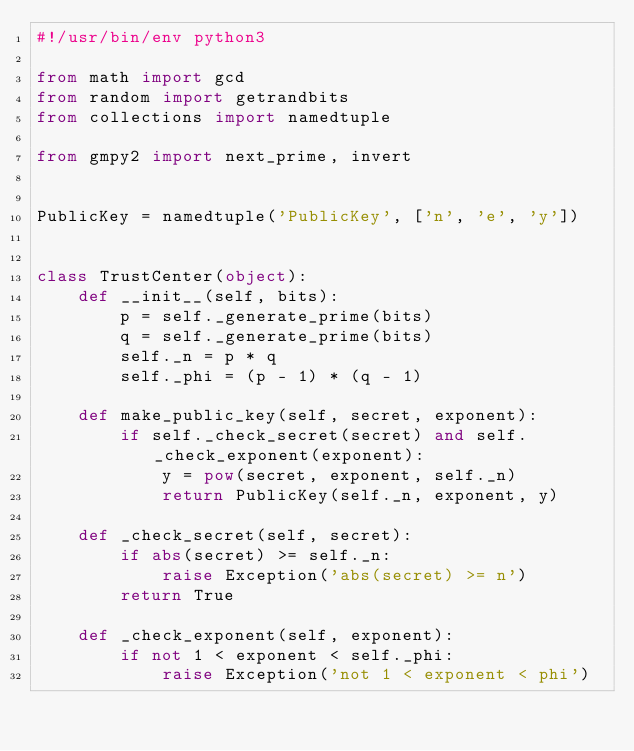Convert code to text. <code><loc_0><loc_0><loc_500><loc_500><_Python_>#!/usr/bin/env python3

from math import gcd
from random import getrandbits
from collections import namedtuple

from gmpy2 import next_prime, invert


PublicKey = namedtuple('PublicKey', ['n', 'e', 'y'])


class TrustCenter(object):
    def __init__(self, bits):
        p = self._generate_prime(bits)
        q = self._generate_prime(bits)
        self._n = p * q
        self._phi = (p - 1) * (q - 1)

    def make_public_key(self, secret, exponent):
        if self._check_secret(secret) and self._check_exponent(exponent):
            y = pow(secret, exponent, self._n)
            return PublicKey(self._n, exponent, y)

    def _check_secret(self, secret):
        if abs(secret) >= self._n:
            raise Exception('abs(secret) >= n')
        return True

    def _check_exponent(self, exponent):
        if not 1 < exponent < self._phi:
            raise Exception('not 1 < exponent < phi')</code> 